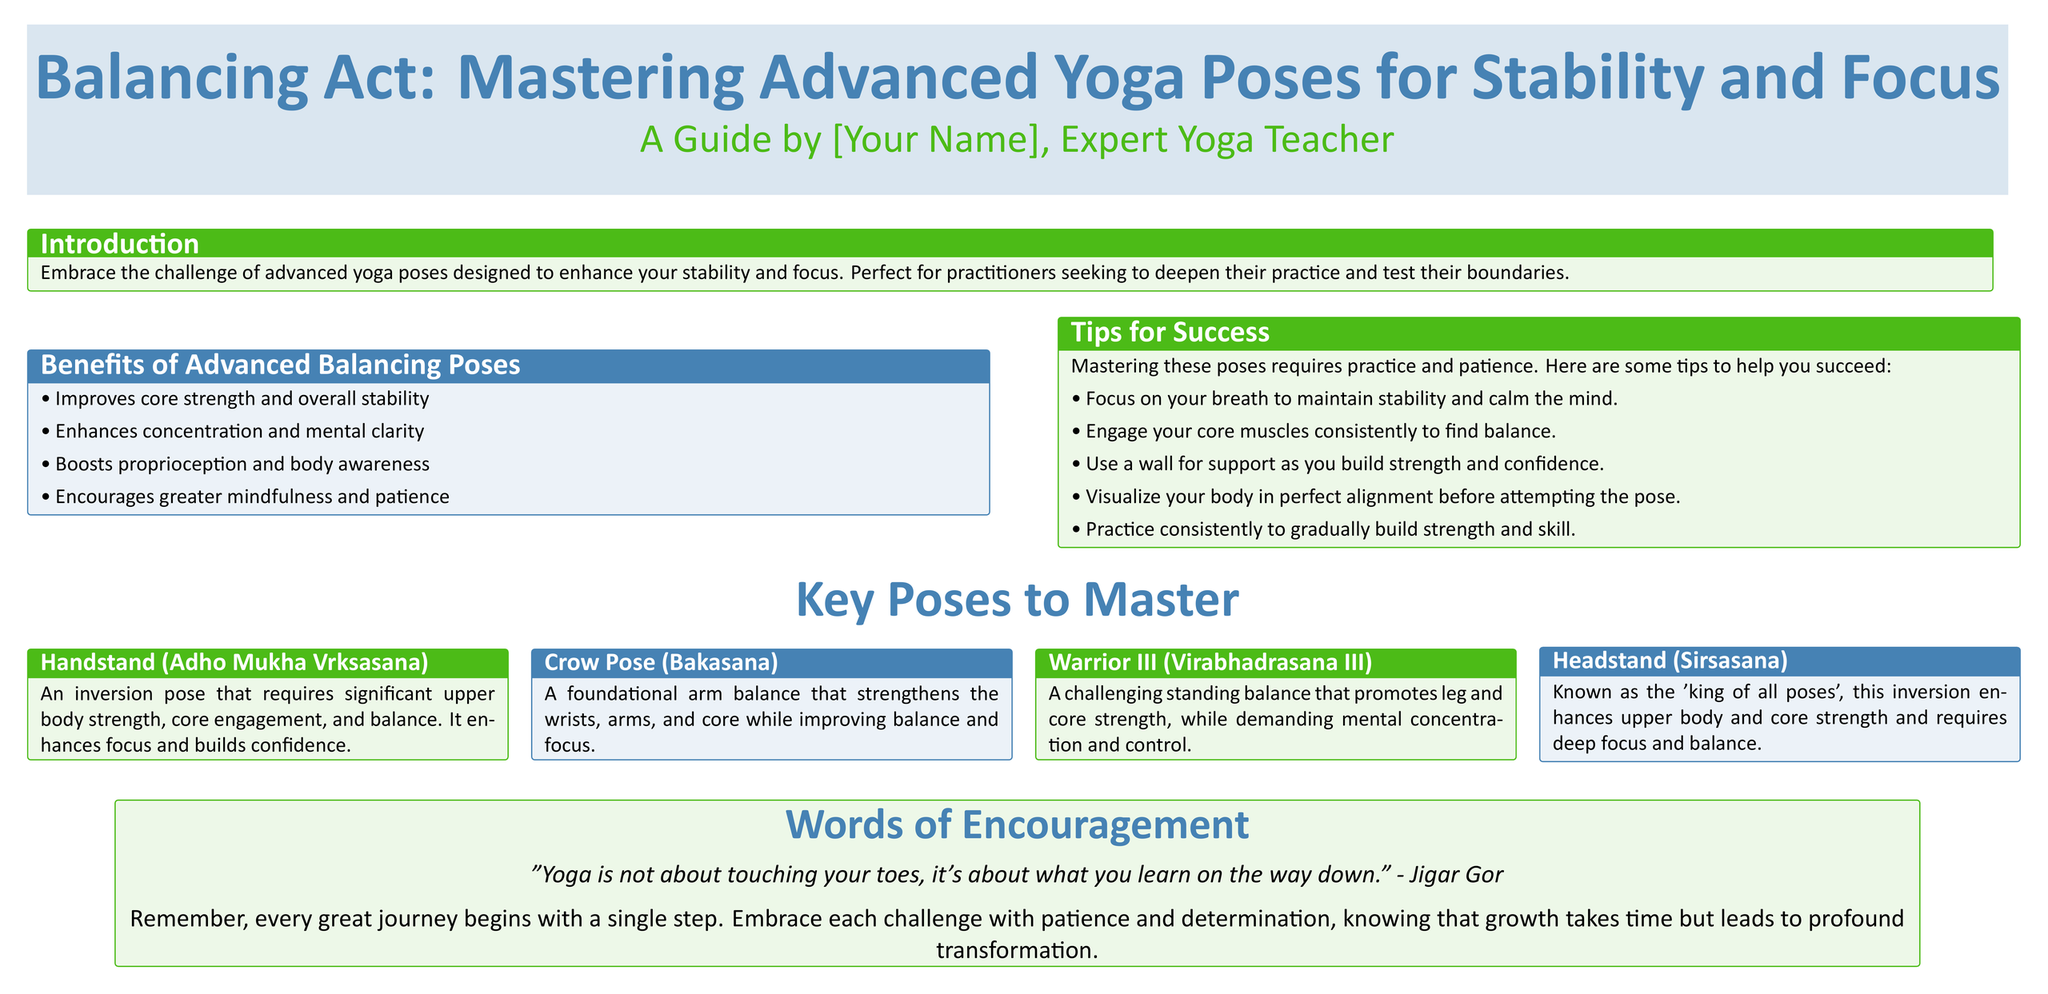What is the title of the poster? The title is prominently displayed at the top of the document, indicating the main focus of the poster on yoga.
Answer: Balancing Act: Mastering Advanced Yoga Poses for Stability and Focus Who is the author of the poster? The author is mentioned below the title, indicating the expertise behind the content.
Answer: [Your Name] What is one benefit of advanced balancing poses? The poster lists several benefits, helping readers understand the advantages of these poses.
Answer: Improves core strength and overall stability What color is used for the tips section? The color coding of sections is mentioned in the document, allowing readers to identify sections easily.
Answer: Yogagreen What is the name of the pose described as the 'king of all poses'? The document includes specific names for each pose, highlighting their significance in advanced yoga practice.
Answer: Headstand (Sirsasana) What quote is included in the "Words of Encouragement" section? The poster features a motivational quote to inspire practitioners in their yoga journey.
Answer: "Yoga is not about touching your toes, it's about what you learn on the way down." - Jigar Gor How many key poses are listed to master? The document presents a section with four key poses, allowing readers to focus on specific advanced poses.
Answer: Four What is a foundational arm balance mentioned in the poster? The poster provides specific examples of advanced poses, one of which is highlighted as a foundational arm balance.
Answer: Crow Pose (Bakasana) What should you focus on to maintain stability according to the tips section? The tips section offers actionable advice for mastering advanced balancing poses.
Answer: Your breath 